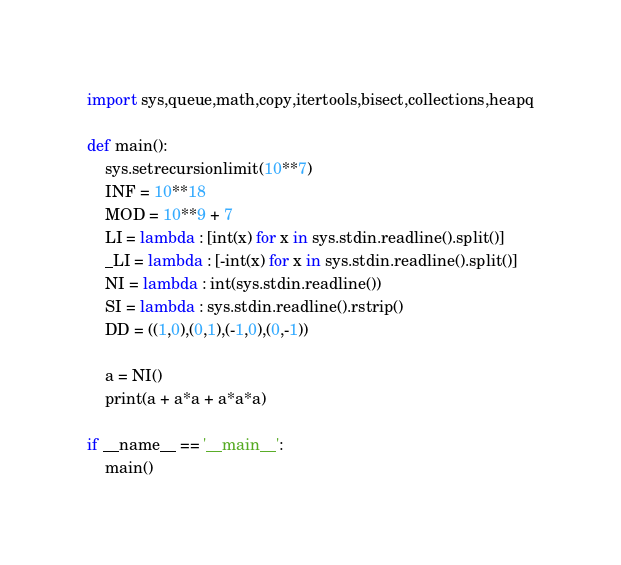<code> <loc_0><loc_0><loc_500><loc_500><_Python_>import sys,queue,math,copy,itertools,bisect,collections,heapq

def main():
    sys.setrecursionlimit(10**7)
    INF = 10**18
    MOD = 10**9 + 7
    LI = lambda : [int(x) for x in sys.stdin.readline().split()]
    _LI = lambda : [-int(x) for x in sys.stdin.readline().split()]
    NI = lambda : int(sys.stdin.readline())
    SI = lambda : sys.stdin.readline().rstrip()
    DD = ((1,0),(0,1),(-1,0),(0,-1))

    a = NI()
    print(a + a*a + a*a*a)

if __name__ == '__main__':
    main()</code> 